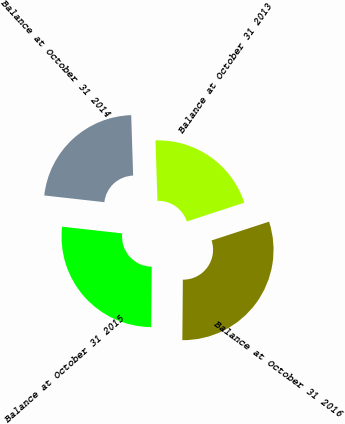Convert chart to OTSL. <chart><loc_0><loc_0><loc_500><loc_500><pie_chart><fcel>Balance at October 31 2013<fcel>Balance at October 31 2014<fcel>Balance at October 31 2015<fcel>Balance at October 31 2016<nl><fcel>20.48%<fcel>22.72%<fcel>26.63%<fcel>30.17%<nl></chart> 